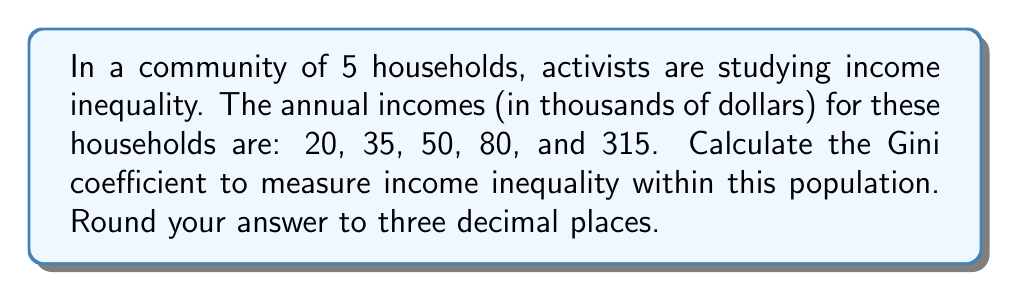Solve this math problem. To calculate the Gini coefficient, we'll follow these steps:

1. Order the incomes from lowest to highest:
   20, 35, 50, 80, 315

2. Calculate the cumulative share of the population (x) and the cumulative share of income (y):

   | Income | Pop. Share | Cum. Pop. Share (x) | Cum. Income | Cum. Income Share (y) |
   |--------|------------|---------------------|-------------|------------------------|
   | 20     | 0.2        | 0.2                 | 20          | 0.04                   |
   | 35     | 0.2        | 0.4                 | 55          | 0.11                   |
   | 50     | 0.2        | 0.6                 | 105         | 0.21                   |
   | 80     | 0.2        | 0.8                 | 185         | 0.37                   |
   | 315    | 0.2        | 1.0                 | 500         | 1.00                   |

3. Calculate the area under the Lorenz curve (B) using the trapezoidal rule:

   $$B = \frac{1}{2} \sum_{i=1}^{n-1} (x_{i+1} - x_i)(y_i + y_{i+1})$$

   $$B = \frac{1}{2}[(0.4-0.2)(0.04+0.11) + (0.6-0.4)(0.11+0.21) + (0.8-0.6)(0.21+0.37) + (1.0-0.8)(0.37+1.00)]$$
   $$B = \frac{1}{2}[0.2(0.15) + 0.2(0.32) + 0.2(0.58) + 0.2(1.37)]$$
   $$B = \frac{1}{2}[0.03 + 0.064 + 0.116 + 0.274] = 0.242$$

4. Calculate the area of perfect equality (A):
   $$A = \frac{1}{2}$$

5. Calculate the Gini coefficient:
   $$G = \frac{A - B}{A} = \frac{0.5 - 0.242}{0.5} = 0.516$$
Answer: The Gini coefficient for this population is 0.516 (rounded to three decimal places). 